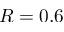<formula> <loc_0><loc_0><loc_500><loc_500>R = 0 . 6</formula> 